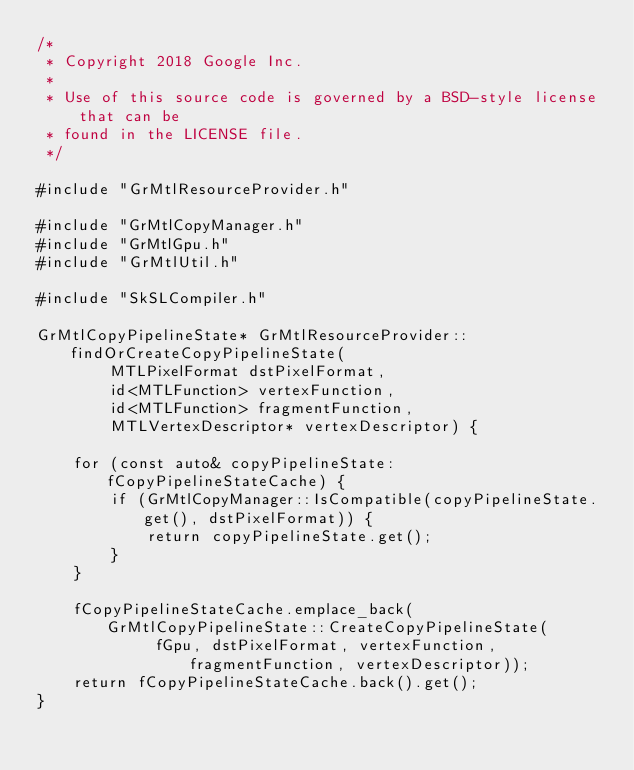<code> <loc_0><loc_0><loc_500><loc_500><_ObjectiveC_>/*
 * Copyright 2018 Google Inc.
 *
 * Use of this source code is governed by a BSD-style license that can be
 * found in the LICENSE file.
 */

#include "GrMtlResourceProvider.h"

#include "GrMtlCopyManager.h"
#include "GrMtlGpu.h"
#include "GrMtlUtil.h"

#include "SkSLCompiler.h"

GrMtlCopyPipelineState* GrMtlResourceProvider::findOrCreateCopyPipelineState(
        MTLPixelFormat dstPixelFormat,
        id<MTLFunction> vertexFunction,
        id<MTLFunction> fragmentFunction,
        MTLVertexDescriptor* vertexDescriptor) {

    for (const auto& copyPipelineState: fCopyPipelineStateCache) {
        if (GrMtlCopyManager::IsCompatible(copyPipelineState.get(), dstPixelFormat)) {
            return copyPipelineState.get();
        }
    }

    fCopyPipelineStateCache.emplace_back(GrMtlCopyPipelineState::CreateCopyPipelineState(
             fGpu, dstPixelFormat, vertexFunction, fragmentFunction, vertexDescriptor));
    return fCopyPipelineStateCache.back().get();
}
</code> 